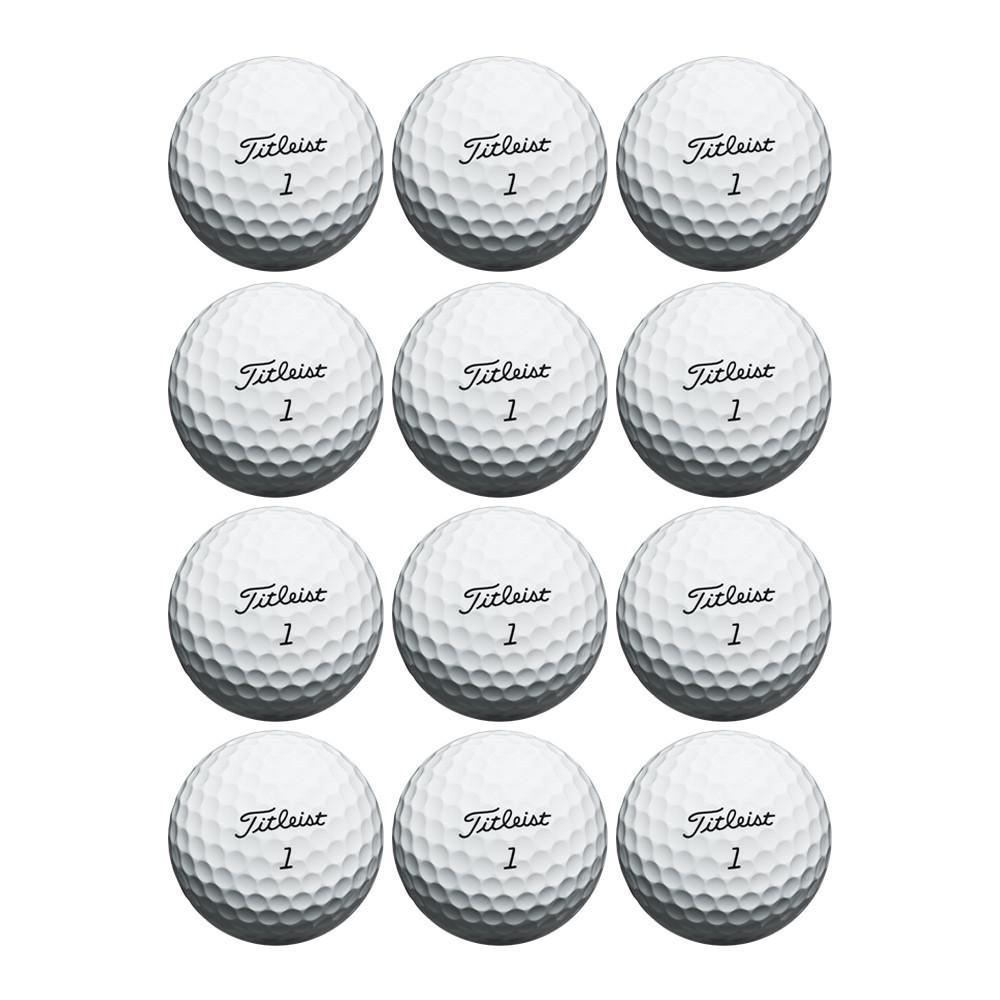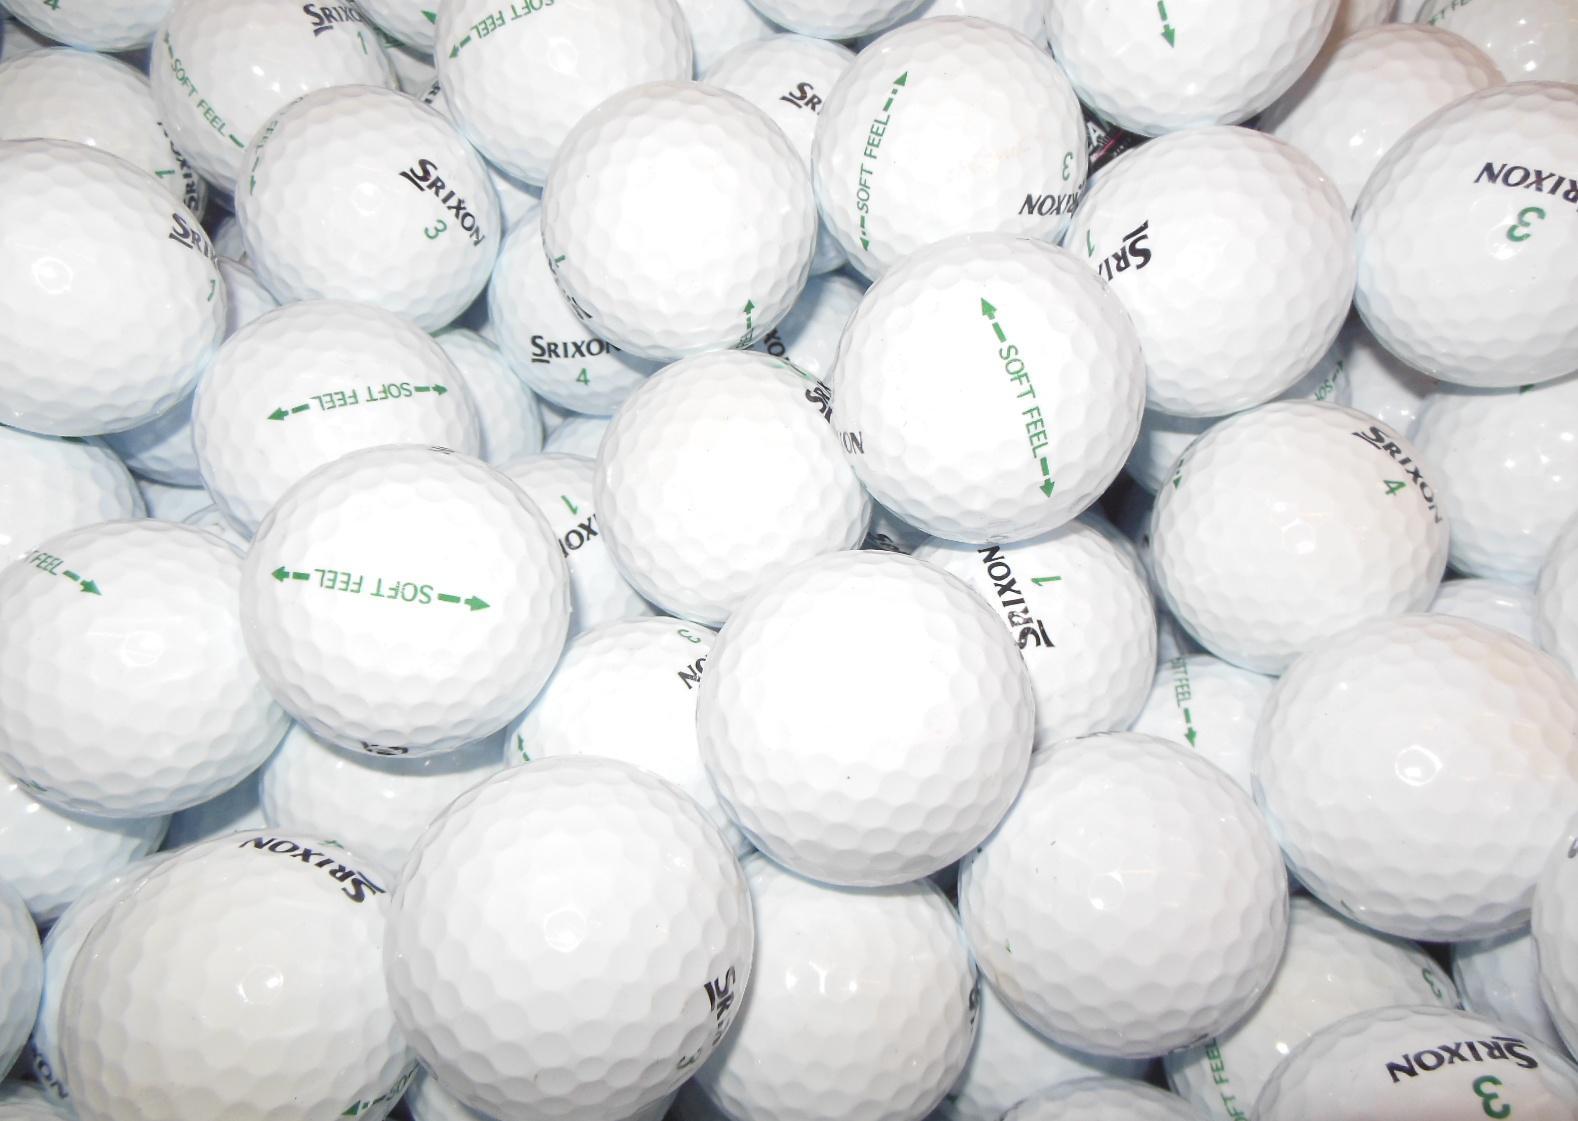The first image is the image on the left, the second image is the image on the right. Given the left and right images, does the statement "In one of the images, 12 golf balls are lined up neatly in a 3x4 or 4x3 pattern." hold true? Answer yes or no. Yes. The first image is the image on the left, the second image is the image on the right. Examine the images to the left and right. Is the description "In at least one image there is a total of 12 golf balls." accurate? Answer yes or no. Yes. 